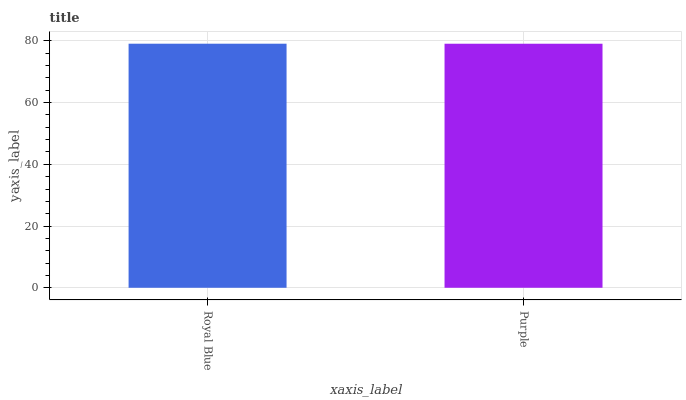Is Purple the maximum?
Answer yes or no. No. Is Royal Blue greater than Purple?
Answer yes or no. Yes. Is Purple less than Royal Blue?
Answer yes or no. Yes. Is Purple greater than Royal Blue?
Answer yes or no. No. Is Royal Blue less than Purple?
Answer yes or no. No. Is Royal Blue the high median?
Answer yes or no. Yes. Is Purple the low median?
Answer yes or no. Yes. Is Purple the high median?
Answer yes or no. No. Is Royal Blue the low median?
Answer yes or no. No. 